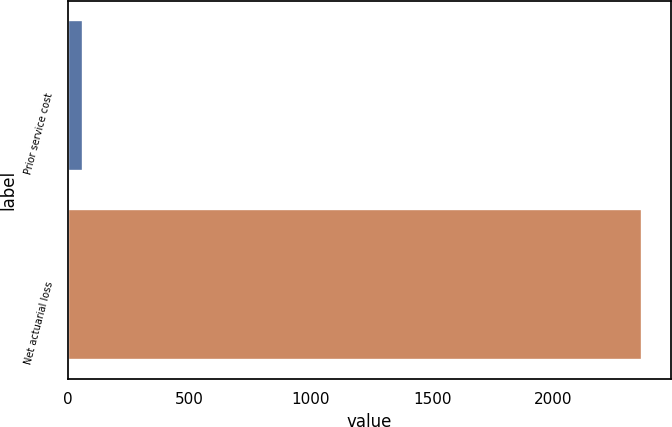Convert chart to OTSL. <chart><loc_0><loc_0><loc_500><loc_500><bar_chart><fcel>Prior service cost<fcel>Net actuarial loss<nl><fcel>62<fcel>2364<nl></chart> 